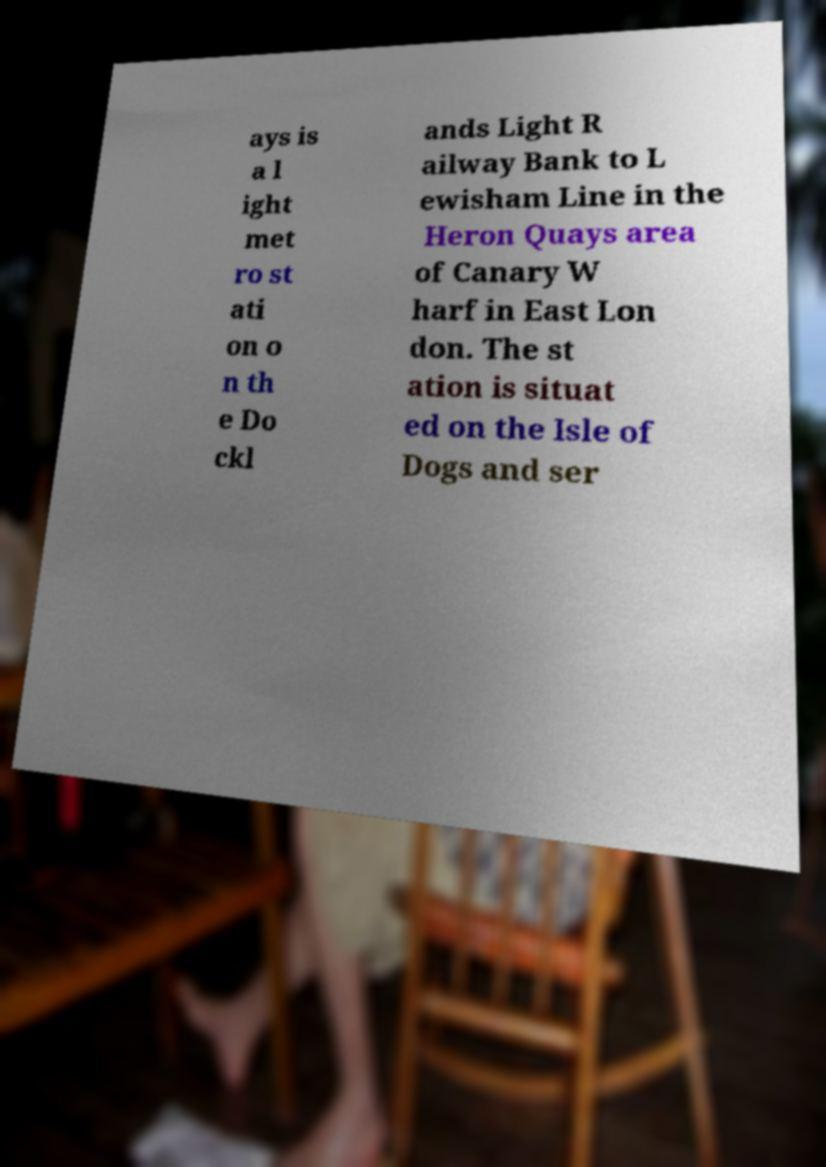Please identify and transcribe the text found in this image. ays is a l ight met ro st ati on o n th e Do ckl ands Light R ailway Bank to L ewisham Line in the Heron Quays area of Canary W harf in East Lon don. The st ation is situat ed on the Isle of Dogs and ser 